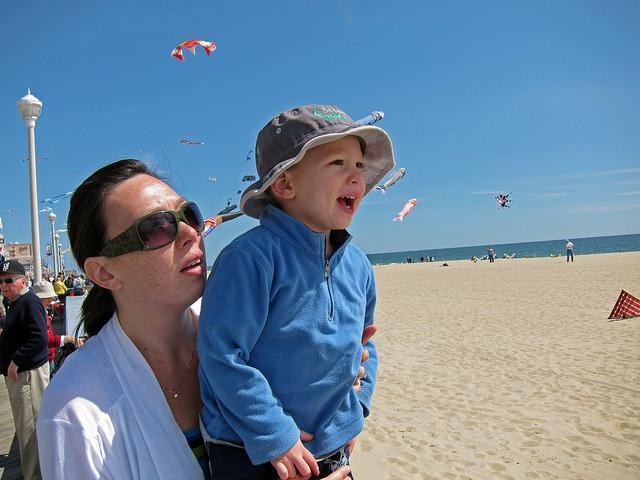How many people can you see?
Give a very brief answer. 3. How many black cats are in the image?
Give a very brief answer. 0. 